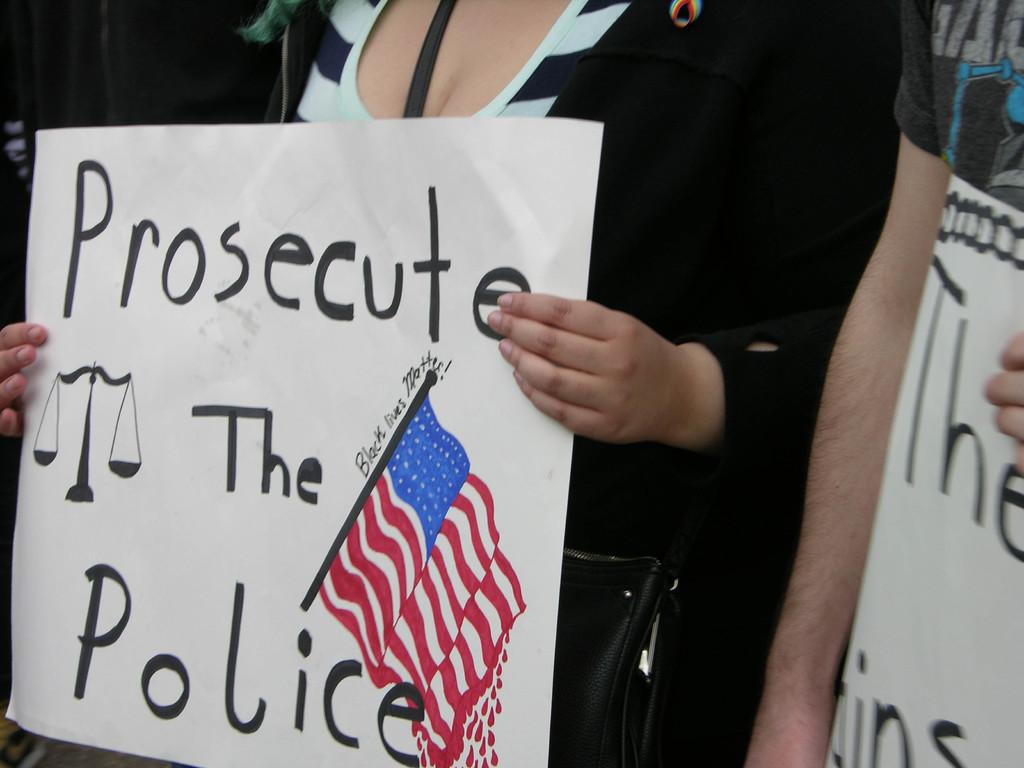<image>
Share a concise interpretation of the image provided. a person is holding a sign to prosecute the police 